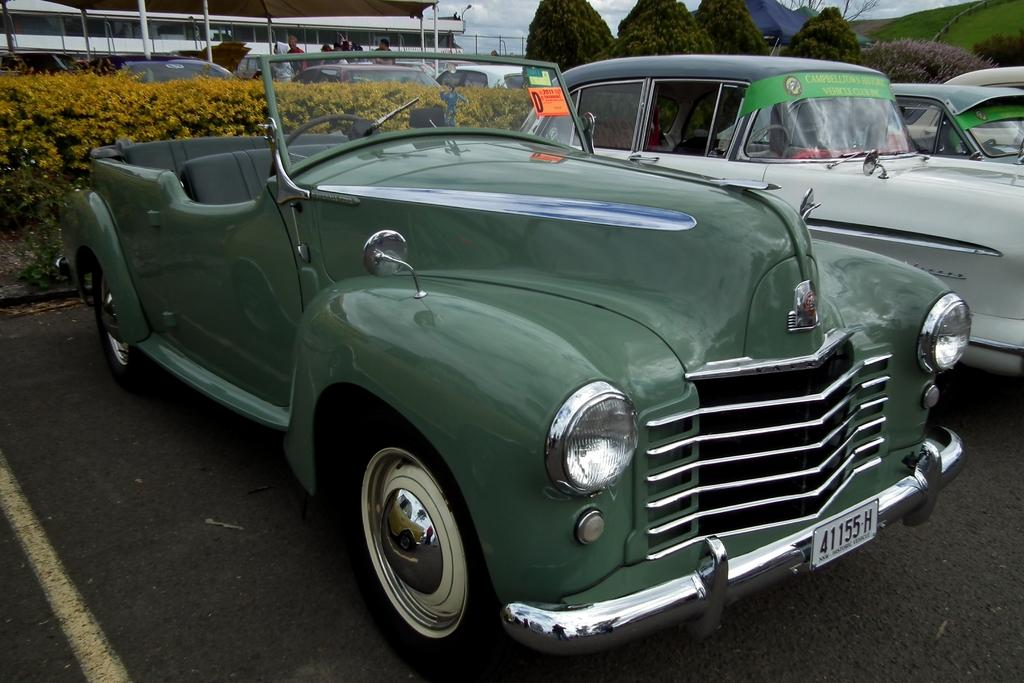What type of vehicles can be seen on the road in the image? There are cars on the road in the image. What type of natural elements are present in the image? There are plants, trees, grass, and the sky visible in the image. What type of temporary structures can be seen in the image? There are tents in the image. What type of barrier can be seen in the image? There is a fence in the image. What type of shelter is present in the image? There is a shelter in the image. Who or what is present in the image? There is a group of people standing in the image. What else can be seen in the image? There are objects in the image. What type of mint is growing in the image? There is no mint plant visible in the image. What type of creature can be seen interacting with the group of people in the image? There are no creatures present in the image; only people, cars, and various structures are visible. 